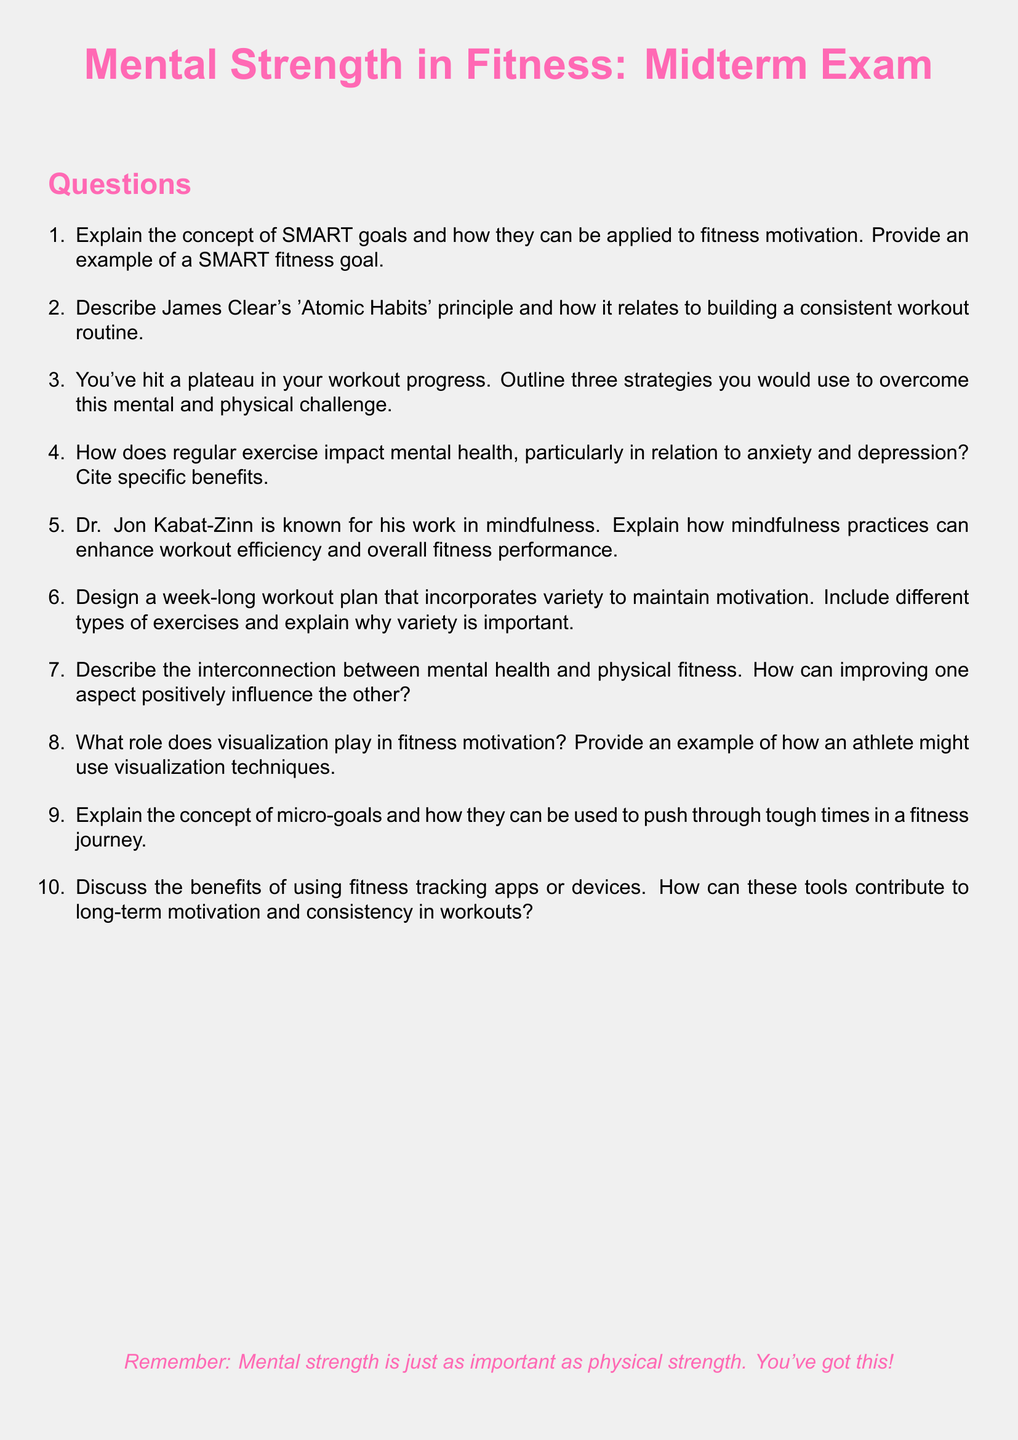what is the title of the document? The title of the document is prominently displayed at the top and is "Mental Strength in Fitness: Midterm Exam."
Answer: Mental Strength in Fitness: Midterm Exam who is associated with the concept of mindfulness in the document? The document mentions Dr. Jon Kabat-Zinn in relation to mindfulness practices.
Answer: Dr. Jon Kabat-Zinn what is an example of a strategy for overcoming a workout plateau? The document asks for three strategies, but one strategy could be changing workout routines or increasing intensity.
Answer: Change workout routines how many types of questions does the exam contain? The document includes a numbered list of questions; there are ten questions total.
Answer: Ten what is the significance of SMART goals in fitness motivation? The document outlines that SMART goals help structure fitness motivation in a specific way.
Answer: Structure motivation which principle is described by James Clear regarding habits? The document refers to "Atomic Habits" as James Clear's principle related to building consistency in workouts.
Answer: Atomic Habits name a benefit of regular exercise mentioned in relation to mental health. The document highlights benefits such as reduced anxiety or improved mood associated with regular exercise.
Answer: Reduced anxiety how does the document recommend maintaining motivation in a workout plan? The document emphasizes incorporating variety into the workout plan to sustain motivation.
Answer: Incorporate variety 